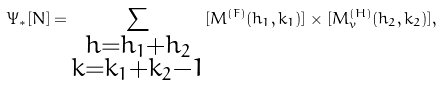Convert formula to latex. <formula><loc_0><loc_0><loc_500><loc_500>\Psi _ { \ast } [ N ] = \sum _ { \substack { h = h _ { 1 } + h _ { 2 } \\ k = k _ { 1 } + k _ { 2 } - 1 } } [ M ^ { ( F ) } ( h _ { 1 } , k _ { 1 } ) ] \times [ M _ { v } ^ { ( H ) } ( h _ { 2 } , k _ { 2 } ) ] ,</formula> 